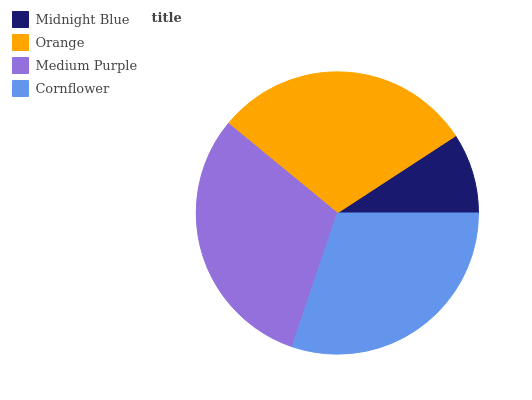Is Midnight Blue the minimum?
Answer yes or no. Yes. Is Medium Purple the maximum?
Answer yes or no. Yes. Is Orange the minimum?
Answer yes or no. No. Is Orange the maximum?
Answer yes or no. No. Is Orange greater than Midnight Blue?
Answer yes or no. Yes. Is Midnight Blue less than Orange?
Answer yes or no. Yes. Is Midnight Blue greater than Orange?
Answer yes or no. No. Is Orange less than Midnight Blue?
Answer yes or no. No. Is Cornflower the high median?
Answer yes or no. Yes. Is Orange the low median?
Answer yes or no. Yes. Is Orange the high median?
Answer yes or no. No. Is Medium Purple the low median?
Answer yes or no. No. 